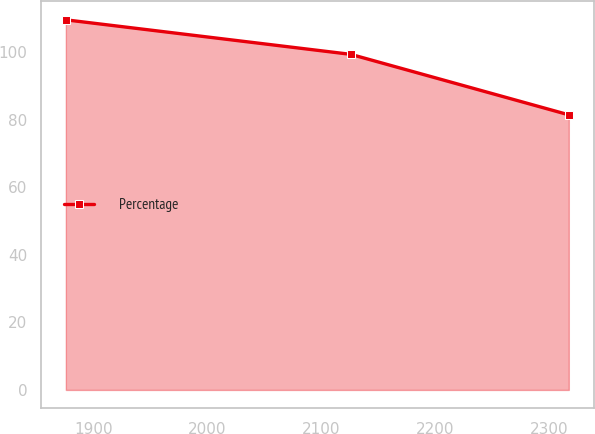Convert chart to OTSL. <chart><loc_0><loc_0><loc_500><loc_500><line_chart><ecel><fcel>Percentage<nl><fcel>1875.94<fcel>109.67<nl><fcel>2126.07<fcel>99.44<nl><fcel>2317.45<fcel>81.52<nl></chart> 